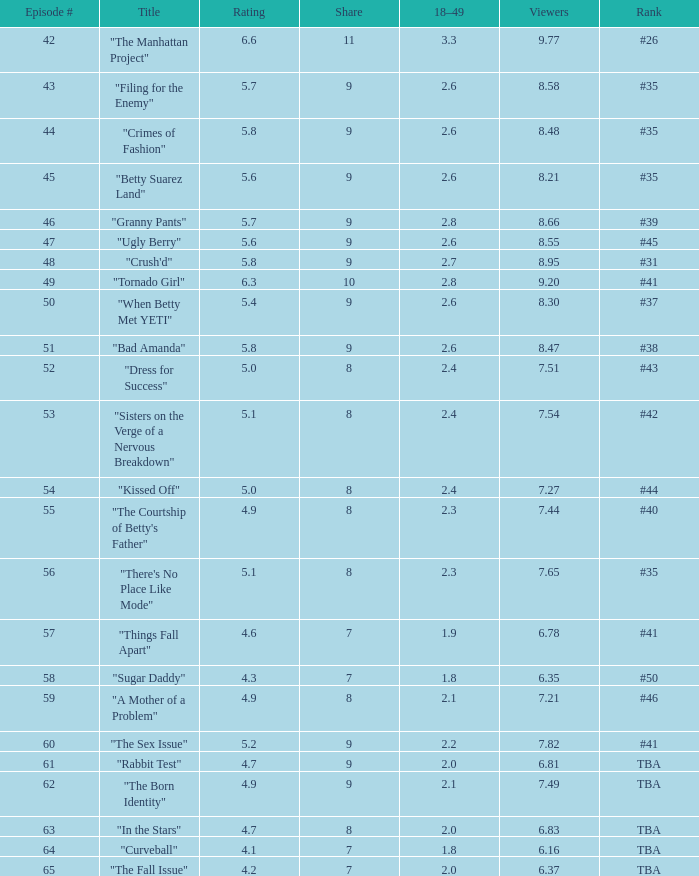What is the total number of Viewers when the rank is #40? 1.0. 